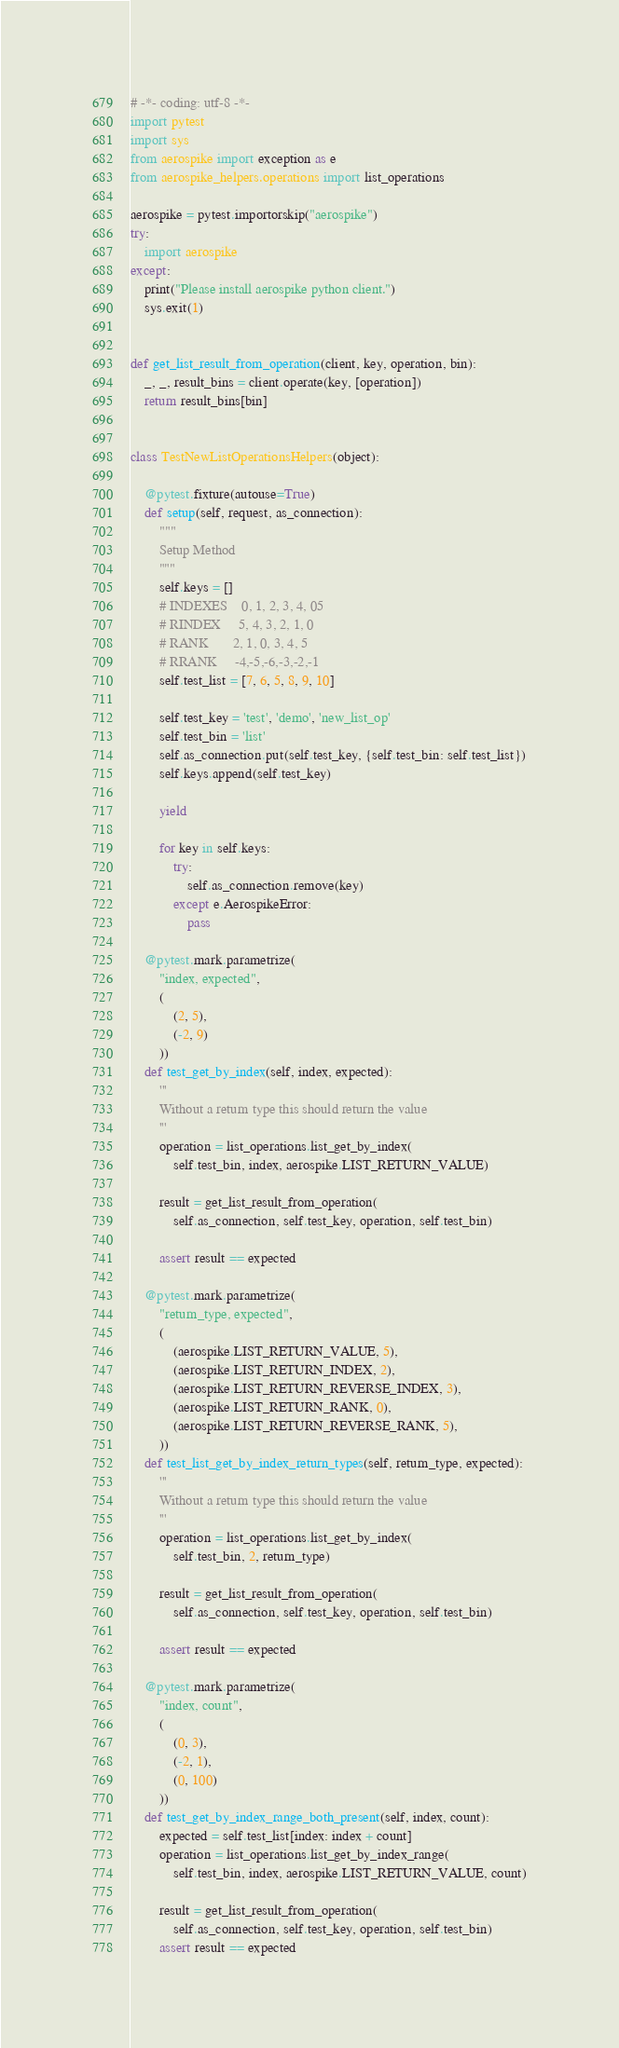<code> <loc_0><loc_0><loc_500><loc_500><_Python_># -*- coding: utf-8 -*-
import pytest
import sys
from aerospike import exception as e
from aerospike_helpers.operations import list_operations

aerospike = pytest.importorskip("aerospike")
try:
    import aerospike
except:
    print("Please install aerospike python client.")
    sys.exit(1)


def get_list_result_from_operation(client, key, operation, bin):
    _, _, result_bins = client.operate(key, [operation])
    return result_bins[bin]


class TestNewListOperationsHelpers(object):

    @pytest.fixture(autouse=True)
    def setup(self, request, as_connection):
        """
        Setup Method
        """
        self.keys = []
        # INDEXES    0, 1, 2, 3, 4, 05
        # RINDEX     5, 4, 3, 2, 1, 0 
        # RANK       2, 1, 0, 3, 4, 5
        # RRANK     -4,-5,-6,-3,-2,-1
        self.test_list = [7, 6, 5, 8, 9, 10]

        self.test_key = 'test', 'demo', 'new_list_op'
        self.test_bin = 'list'
        self.as_connection.put(self.test_key, {self.test_bin: self.test_list})
        self.keys.append(self.test_key)

        yield

        for key in self.keys:
            try:
                self.as_connection.remove(key)
            except e.AerospikeError:
                pass

    @pytest.mark.parametrize(
        "index, expected",
        (
            (2, 5),
            (-2, 9)
        ))
    def test_get_by_index(self, index, expected):
        '''
        Without a return type this should return the value
        '''
        operation = list_operations.list_get_by_index(
            self.test_bin, index, aerospike.LIST_RETURN_VALUE)

        result = get_list_result_from_operation(
            self.as_connection, self.test_key, operation, self.test_bin)
        
        assert result == expected

    @pytest.mark.parametrize(
        "return_type, expected",
        (
            (aerospike.LIST_RETURN_VALUE, 5),
            (aerospike.LIST_RETURN_INDEX, 2),
            (aerospike.LIST_RETURN_REVERSE_INDEX, 3),
            (aerospike.LIST_RETURN_RANK, 0),
            (aerospike.LIST_RETURN_REVERSE_RANK, 5),
        ))
    def test_list_get_by_index_return_types(self, return_type, expected):
        '''
        Without a return type this should return the value
        '''
        operation = list_operations.list_get_by_index(
            self.test_bin, 2, return_type)

        result = get_list_result_from_operation(
            self.as_connection, self.test_key, operation, self.test_bin)
        
        assert result == expected

    @pytest.mark.parametrize(
        "index, count",
        (
            (0, 3),
            (-2, 1),
            (0, 100)
        ))
    def test_get_by_index_range_both_present(self, index, count):
        expected = self.test_list[index: index + count]
        operation = list_operations.list_get_by_index_range(
            self.test_bin, index, aerospike.LIST_RETURN_VALUE, count)

        result = get_list_result_from_operation(
            self.as_connection, self.test_key, operation, self.test_bin)
        assert result == expected
</code> 